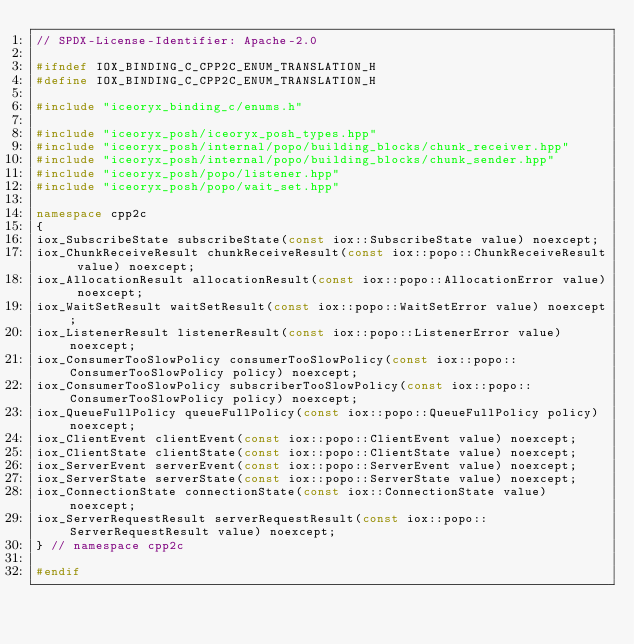<code> <loc_0><loc_0><loc_500><loc_500><_C++_>// SPDX-License-Identifier: Apache-2.0

#ifndef IOX_BINDING_C_CPP2C_ENUM_TRANSLATION_H
#define IOX_BINDING_C_CPP2C_ENUM_TRANSLATION_H

#include "iceoryx_binding_c/enums.h"

#include "iceoryx_posh/iceoryx_posh_types.hpp"
#include "iceoryx_posh/internal/popo/building_blocks/chunk_receiver.hpp"
#include "iceoryx_posh/internal/popo/building_blocks/chunk_sender.hpp"
#include "iceoryx_posh/popo/listener.hpp"
#include "iceoryx_posh/popo/wait_set.hpp"

namespace cpp2c
{
iox_SubscribeState subscribeState(const iox::SubscribeState value) noexcept;
iox_ChunkReceiveResult chunkReceiveResult(const iox::popo::ChunkReceiveResult value) noexcept;
iox_AllocationResult allocationResult(const iox::popo::AllocationError value) noexcept;
iox_WaitSetResult waitSetResult(const iox::popo::WaitSetError value) noexcept;
iox_ListenerResult listenerResult(const iox::popo::ListenerError value) noexcept;
iox_ConsumerTooSlowPolicy consumerTooSlowPolicy(const iox::popo::ConsumerTooSlowPolicy policy) noexcept;
iox_ConsumerTooSlowPolicy subscriberTooSlowPolicy(const iox::popo::ConsumerTooSlowPolicy policy) noexcept;
iox_QueueFullPolicy queueFullPolicy(const iox::popo::QueueFullPolicy policy) noexcept;
iox_ClientEvent clientEvent(const iox::popo::ClientEvent value) noexcept;
iox_ClientState clientState(const iox::popo::ClientState value) noexcept;
iox_ServerEvent serverEvent(const iox::popo::ServerEvent value) noexcept;
iox_ServerState serverState(const iox::popo::ServerState value) noexcept;
iox_ConnectionState connectionState(const iox::ConnectionState value) noexcept;
iox_ServerRequestResult serverRequestResult(const iox::popo::ServerRequestResult value) noexcept;
} // namespace cpp2c

#endif
</code> 